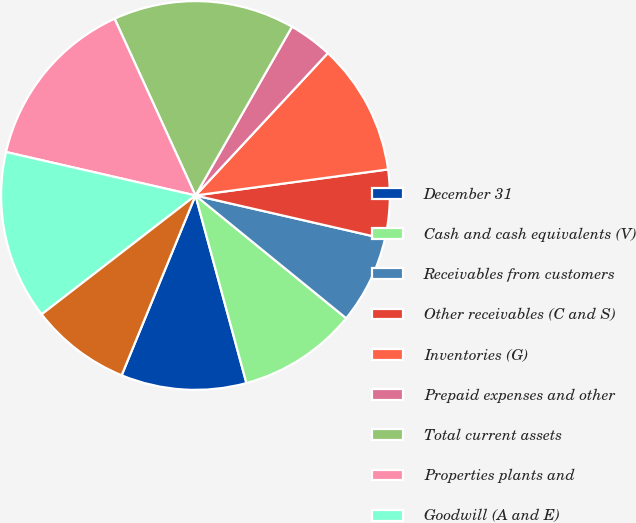Convert chart to OTSL. <chart><loc_0><loc_0><loc_500><loc_500><pie_chart><fcel>December 31<fcel>Cash and cash equivalents (V)<fcel>Receivables from customers<fcel>Other receivables (C and S)<fcel>Inventories (G)<fcel>Prepaid expenses and other<fcel>Total current assets<fcel>Properties plants and<fcel>Goodwill (A and E)<fcel>Deferred income taxes (R)<nl><fcel>10.42%<fcel>9.9%<fcel>7.29%<fcel>5.73%<fcel>10.94%<fcel>3.65%<fcel>15.1%<fcel>14.58%<fcel>14.06%<fcel>8.33%<nl></chart> 